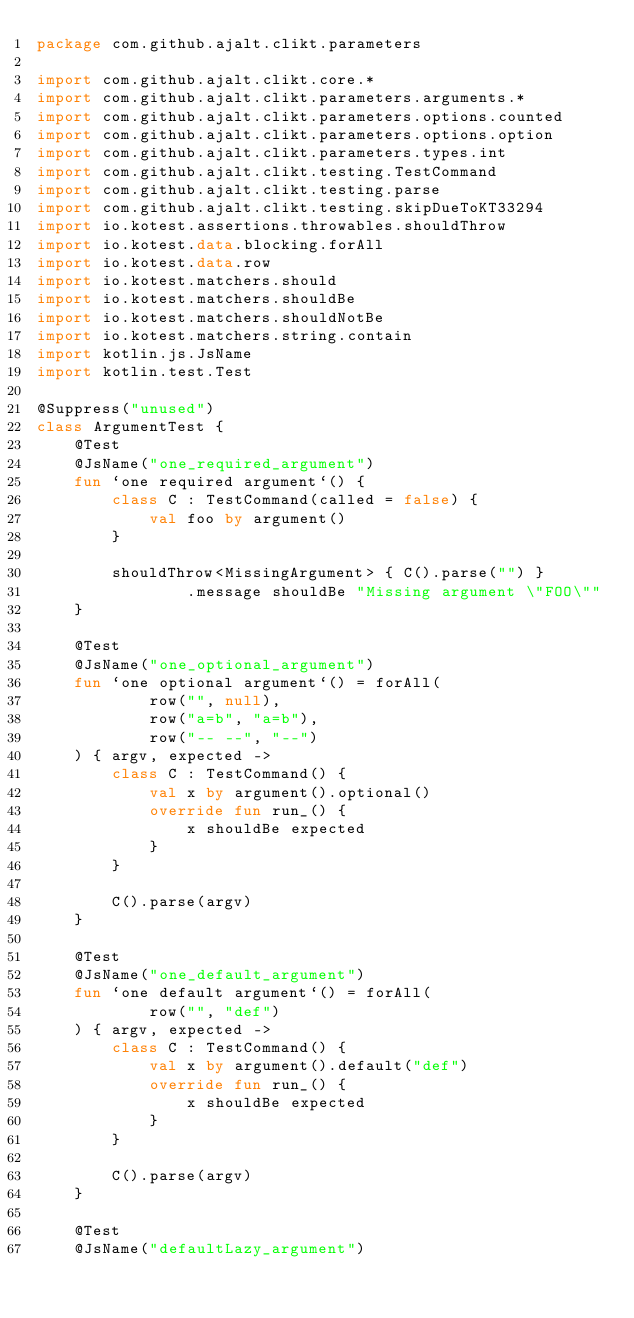Convert code to text. <code><loc_0><loc_0><loc_500><loc_500><_Kotlin_>package com.github.ajalt.clikt.parameters

import com.github.ajalt.clikt.core.*
import com.github.ajalt.clikt.parameters.arguments.*
import com.github.ajalt.clikt.parameters.options.counted
import com.github.ajalt.clikt.parameters.options.option
import com.github.ajalt.clikt.parameters.types.int
import com.github.ajalt.clikt.testing.TestCommand
import com.github.ajalt.clikt.testing.parse
import com.github.ajalt.clikt.testing.skipDueToKT33294
import io.kotest.assertions.throwables.shouldThrow
import io.kotest.data.blocking.forAll
import io.kotest.data.row
import io.kotest.matchers.should
import io.kotest.matchers.shouldBe
import io.kotest.matchers.shouldNotBe
import io.kotest.matchers.string.contain
import kotlin.js.JsName
import kotlin.test.Test

@Suppress("unused")
class ArgumentTest {
    @Test
    @JsName("one_required_argument")
    fun `one required argument`() {
        class C : TestCommand(called = false) {
            val foo by argument()
        }

        shouldThrow<MissingArgument> { C().parse("") }
                .message shouldBe "Missing argument \"FOO\""
    }

    @Test
    @JsName("one_optional_argument")
    fun `one optional argument`() = forAll(
            row("", null),
            row("a=b", "a=b"),
            row("-- --", "--")
    ) { argv, expected ->
        class C : TestCommand() {
            val x by argument().optional()
            override fun run_() {
                x shouldBe expected
            }
        }

        C().parse(argv)
    }

    @Test
    @JsName("one_default_argument")
    fun `one default argument`() = forAll(
            row("", "def")
    ) { argv, expected ->
        class C : TestCommand() {
            val x by argument().default("def")
            override fun run_() {
                x shouldBe expected
            }
        }

        C().parse(argv)
    }

    @Test
    @JsName("defaultLazy_argument")</code> 